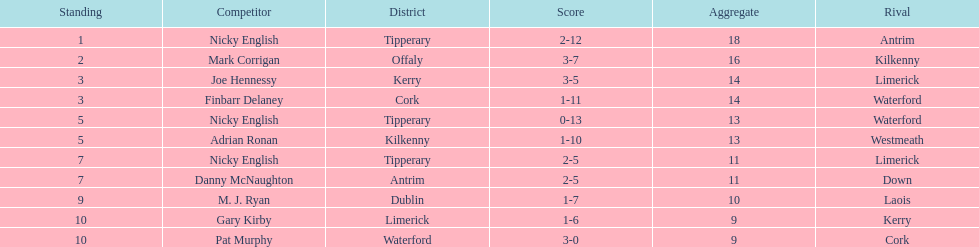Could you parse the entire table? {'header': ['Standing', 'Competitor', 'District', 'Score', 'Aggregate', 'Rival'], 'rows': [['1', 'Nicky English', 'Tipperary', '2-12', '18', 'Antrim'], ['2', 'Mark Corrigan', 'Offaly', '3-7', '16', 'Kilkenny'], ['3', 'Joe Hennessy', 'Kerry', '3-5', '14', 'Limerick'], ['3', 'Finbarr Delaney', 'Cork', '1-11', '14', 'Waterford'], ['5', 'Nicky English', 'Tipperary', '0-13', '13', 'Waterford'], ['5', 'Adrian Ronan', 'Kilkenny', '1-10', '13', 'Westmeath'], ['7', 'Nicky English', 'Tipperary', '2-5', '11', 'Limerick'], ['7', 'Danny McNaughton', 'Antrim', '2-5', '11', 'Down'], ['9', 'M. J. Ryan', 'Dublin', '1-7', '10', 'Laois'], ['10', 'Gary Kirby', 'Limerick', '1-6', '9', 'Kerry'], ['10', 'Pat Murphy', 'Waterford', '3-0', '9', 'Cork']]} What was the combined total of nicky english and mark corrigan? 34. 